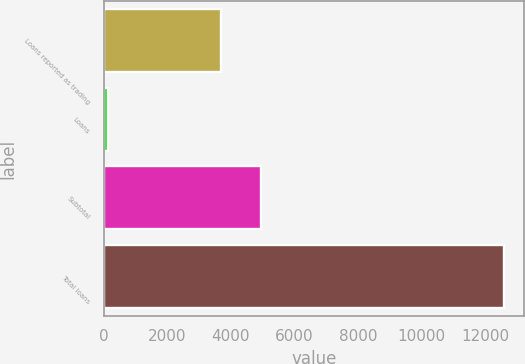Convert chart to OTSL. <chart><loc_0><loc_0><loc_500><loc_500><bar_chart><fcel>Loans reported as trading<fcel>Loans<fcel>Subtotal<fcel>Total loans<nl><fcel>3696<fcel>138<fcel>4941.5<fcel>12593<nl></chart> 